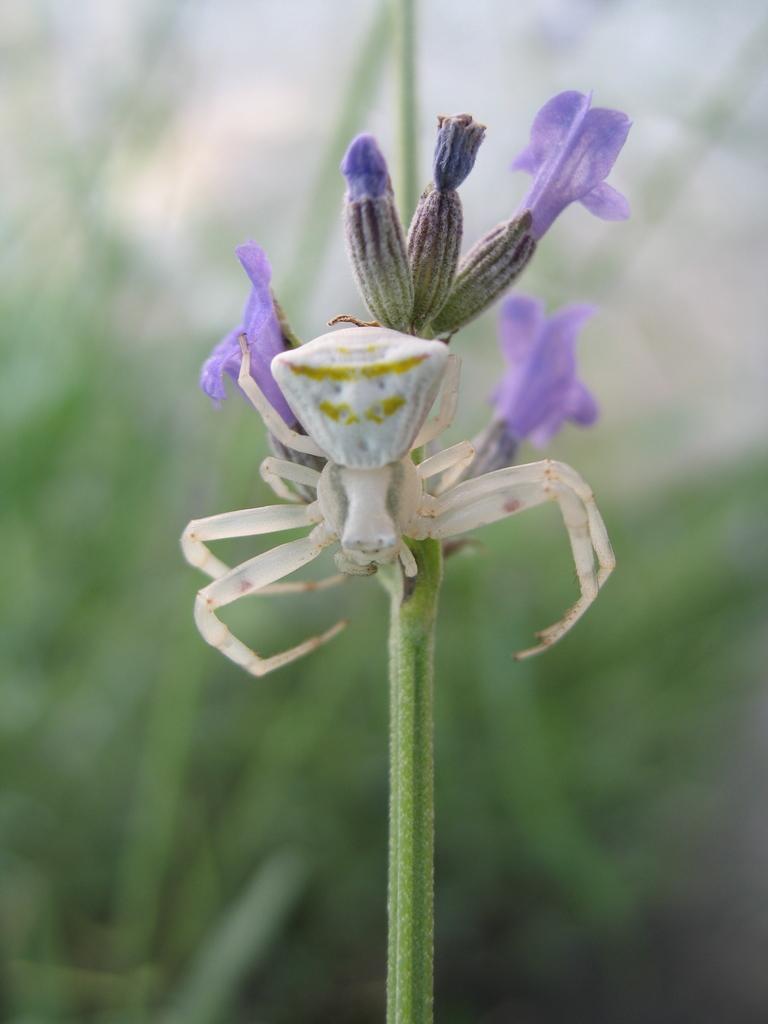Describe this image in one or two sentences. In this image we can see flowers to the stem and a spider on it. 